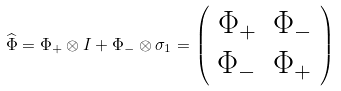Convert formula to latex. <formula><loc_0><loc_0><loc_500><loc_500>\widehat { \Phi } = \Phi _ { + } \otimes I + \Phi _ { - } \otimes \sigma _ { 1 } = \left ( \begin{array} { c c } \Phi _ { + } & \Phi _ { - } \\ \Phi _ { - } & \Phi _ { + } \end{array} \right )</formula> 